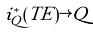<formula> <loc_0><loc_0><loc_500><loc_500>i _ { Q } ^ { * } ( T E ) \rightarrow Q</formula> 